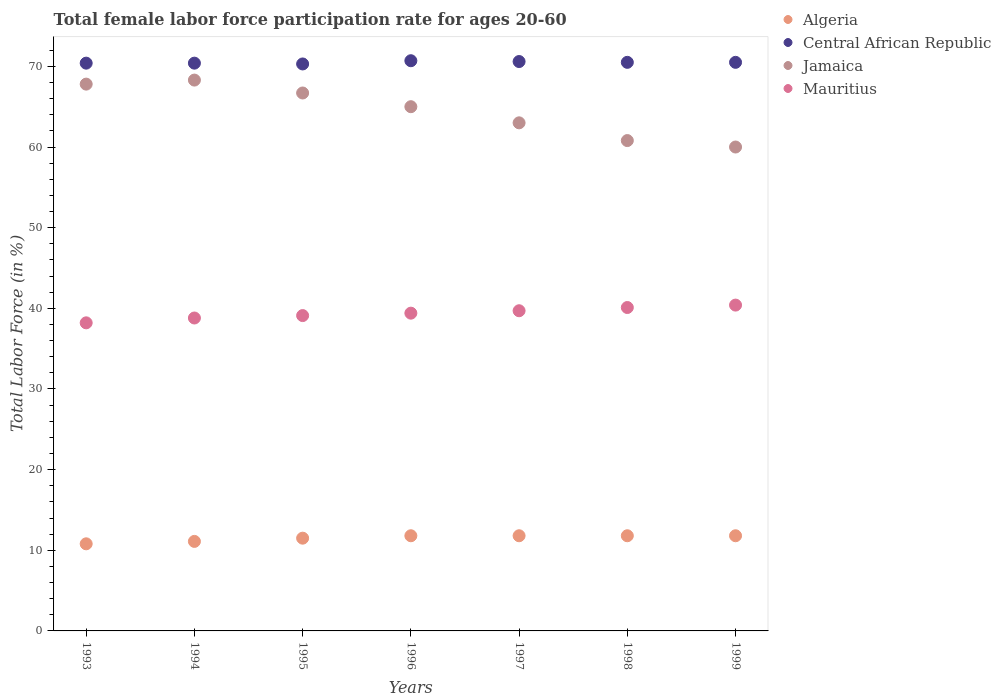What is the female labor force participation rate in Algeria in 1998?
Provide a short and direct response. 11.8. Across all years, what is the maximum female labor force participation rate in Jamaica?
Give a very brief answer. 68.3. In which year was the female labor force participation rate in Algeria minimum?
Ensure brevity in your answer.  1993. What is the total female labor force participation rate in Algeria in the graph?
Provide a short and direct response. 80.6. What is the difference between the female labor force participation rate in Central African Republic in 1994 and that in 1997?
Ensure brevity in your answer.  -0.2. What is the difference between the female labor force participation rate in Central African Republic in 1997 and the female labor force participation rate in Algeria in 1995?
Make the answer very short. 59.1. What is the average female labor force participation rate in Mauritius per year?
Your answer should be compact. 39.39. In how many years, is the female labor force participation rate in Algeria greater than 22 %?
Your answer should be compact. 0. What is the ratio of the female labor force participation rate in Jamaica in 1997 to that in 1998?
Offer a very short reply. 1.04. What is the difference between the highest and the second highest female labor force participation rate in Mauritius?
Keep it short and to the point. 0.3. What is the difference between the highest and the lowest female labor force participation rate in Mauritius?
Give a very brief answer. 2.2. Is the sum of the female labor force participation rate in Mauritius in 1994 and 1996 greater than the maximum female labor force participation rate in Algeria across all years?
Your response must be concise. Yes. Is it the case that in every year, the sum of the female labor force participation rate in Mauritius and female labor force participation rate in Central African Republic  is greater than the sum of female labor force participation rate in Algeria and female labor force participation rate in Jamaica?
Provide a succinct answer. No. Is it the case that in every year, the sum of the female labor force participation rate in Jamaica and female labor force participation rate in Algeria  is greater than the female labor force participation rate in Central African Republic?
Give a very brief answer. Yes. Does the female labor force participation rate in Jamaica monotonically increase over the years?
Give a very brief answer. No. Is the female labor force participation rate in Algeria strictly greater than the female labor force participation rate in Central African Republic over the years?
Offer a terse response. No. How many years are there in the graph?
Give a very brief answer. 7. Are the values on the major ticks of Y-axis written in scientific E-notation?
Give a very brief answer. No. Does the graph contain any zero values?
Your answer should be compact. No. Does the graph contain grids?
Make the answer very short. No. Where does the legend appear in the graph?
Make the answer very short. Top right. How are the legend labels stacked?
Your response must be concise. Vertical. What is the title of the graph?
Provide a short and direct response. Total female labor force participation rate for ages 20-60. Does "Mauritius" appear as one of the legend labels in the graph?
Your answer should be very brief. Yes. What is the label or title of the X-axis?
Keep it short and to the point. Years. What is the Total Labor Force (in %) of Algeria in 1993?
Your answer should be compact. 10.8. What is the Total Labor Force (in %) of Central African Republic in 1993?
Make the answer very short. 70.4. What is the Total Labor Force (in %) of Jamaica in 1993?
Give a very brief answer. 67.8. What is the Total Labor Force (in %) in Mauritius in 1993?
Your answer should be compact. 38.2. What is the Total Labor Force (in %) in Algeria in 1994?
Keep it short and to the point. 11.1. What is the Total Labor Force (in %) of Central African Republic in 1994?
Offer a very short reply. 70.4. What is the Total Labor Force (in %) in Jamaica in 1994?
Your answer should be compact. 68.3. What is the Total Labor Force (in %) in Mauritius in 1994?
Keep it short and to the point. 38.8. What is the Total Labor Force (in %) in Algeria in 1995?
Ensure brevity in your answer.  11.5. What is the Total Labor Force (in %) of Central African Republic in 1995?
Your answer should be very brief. 70.3. What is the Total Labor Force (in %) of Jamaica in 1995?
Provide a succinct answer. 66.7. What is the Total Labor Force (in %) of Mauritius in 1995?
Offer a terse response. 39.1. What is the Total Labor Force (in %) of Algeria in 1996?
Offer a terse response. 11.8. What is the Total Labor Force (in %) of Central African Republic in 1996?
Offer a terse response. 70.7. What is the Total Labor Force (in %) of Jamaica in 1996?
Offer a terse response. 65. What is the Total Labor Force (in %) of Mauritius in 1996?
Your answer should be very brief. 39.4. What is the Total Labor Force (in %) in Algeria in 1997?
Provide a succinct answer. 11.8. What is the Total Labor Force (in %) of Central African Republic in 1997?
Ensure brevity in your answer.  70.6. What is the Total Labor Force (in %) in Mauritius in 1997?
Keep it short and to the point. 39.7. What is the Total Labor Force (in %) in Algeria in 1998?
Your answer should be very brief. 11.8. What is the Total Labor Force (in %) of Central African Republic in 1998?
Make the answer very short. 70.5. What is the Total Labor Force (in %) in Jamaica in 1998?
Give a very brief answer. 60.8. What is the Total Labor Force (in %) of Mauritius in 1998?
Provide a succinct answer. 40.1. What is the Total Labor Force (in %) in Algeria in 1999?
Offer a very short reply. 11.8. What is the Total Labor Force (in %) of Central African Republic in 1999?
Keep it short and to the point. 70.5. What is the Total Labor Force (in %) in Mauritius in 1999?
Ensure brevity in your answer.  40.4. Across all years, what is the maximum Total Labor Force (in %) of Algeria?
Ensure brevity in your answer.  11.8. Across all years, what is the maximum Total Labor Force (in %) in Central African Republic?
Your response must be concise. 70.7. Across all years, what is the maximum Total Labor Force (in %) of Jamaica?
Offer a very short reply. 68.3. Across all years, what is the maximum Total Labor Force (in %) of Mauritius?
Your answer should be compact. 40.4. Across all years, what is the minimum Total Labor Force (in %) in Algeria?
Your answer should be compact. 10.8. Across all years, what is the minimum Total Labor Force (in %) in Central African Republic?
Make the answer very short. 70.3. Across all years, what is the minimum Total Labor Force (in %) of Mauritius?
Your answer should be very brief. 38.2. What is the total Total Labor Force (in %) in Algeria in the graph?
Your answer should be very brief. 80.6. What is the total Total Labor Force (in %) of Central African Republic in the graph?
Keep it short and to the point. 493.4. What is the total Total Labor Force (in %) in Jamaica in the graph?
Offer a very short reply. 451.6. What is the total Total Labor Force (in %) of Mauritius in the graph?
Offer a terse response. 275.7. What is the difference between the Total Labor Force (in %) in Algeria in 1993 and that in 1994?
Your answer should be very brief. -0.3. What is the difference between the Total Labor Force (in %) of Jamaica in 1993 and that in 1995?
Offer a very short reply. 1.1. What is the difference between the Total Labor Force (in %) of Algeria in 1993 and that in 1998?
Provide a succinct answer. -1. What is the difference between the Total Labor Force (in %) of Jamaica in 1993 and that in 1998?
Provide a succinct answer. 7. What is the difference between the Total Labor Force (in %) of Central African Republic in 1993 and that in 1999?
Make the answer very short. -0.1. What is the difference between the Total Labor Force (in %) of Algeria in 1994 and that in 1995?
Your answer should be very brief. -0.4. What is the difference between the Total Labor Force (in %) in Jamaica in 1994 and that in 1995?
Your answer should be very brief. 1.6. What is the difference between the Total Labor Force (in %) of Mauritius in 1994 and that in 1995?
Provide a succinct answer. -0.3. What is the difference between the Total Labor Force (in %) of Algeria in 1994 and that in 1996?
Your answer should be very brief. -0.7. What is the difference between the Total Labor Force (in %) of Jamaica in 1994 and that in 1996?
Give a very brief answer. 3.3. What is the difference between the Total Labor Force (in %) of Mauritius in 1994 and that in 1996?
Your answer should be compact. -0.6. What is the difference between the Total Labor Force (in %) in Algeria in 1994 and that in 1997?
Offer a very short reply. -0.7. What is the difference between the Total Labor Force (in %) in Jamaica in 1994 and that in 1997?
Provide a short and direct response. 5.3. What is the difference between the Total Labor Force (in %) of Central African Republic in 1994 and that in 1998?
Make the answer very short. -0.1. What is the difference between the Total Labor Force (in %) in Mauritius in 1994 and that in 1998?
Make the answer very short. -1.3. What is the difference between the Total Labor Force (in %) of Algeria in 1994 and that in 1999?
Offer a terse response. -0.7. What is the difference between the Total Labor Force (in %) of Mauritius in 1994 and that in 1999?
Your response must be concise. -1.6. What is the difference between the Total Labor Force (in %) of Algeria in 1995 and that in 1996?
Ensure brevity in your answer.  -0.3. What is the difference between the Total Labor Force (in %) of Central African Republic in 1995 and that in 1996?
Your answer should be very brief. -0.4. What is the difference between the Total Labor Force (in %) in Jamaica in 1995 and that in 1996?
Make the answer very short. 1.7. What is the difference between the Total Labor Force (in %) of Algeria in 1995 and that in 1997?
Your response must be concise. -0.3. What is the difference between the Total Labor Force (in %) of Central African Republic in 1995 and that in 1997?
Provide a short and direct response. -0.3. What is the difference between the Total Labor Force (in %) in Algeria in 1995 and that in 1998?
Provide a short and direct response. -0.3. What is the difference between the Total Labor Force (in %) in Mauritius in 1995 and that in 1998?
Your answer should be compact. -1. What is the difference between the Total Labor Force (in %) of Central African Republic in 1996 and that in 1997?
Your answer should be very brief. 0.1. What is the difference between the Total Labor Force (in %) of Mauritius in 1996 and that in 1997?
Offer a very short reply. -0.3. What is the difference between the Total Labor Force (in %) of Algeria in 1996 and that in 1998?
Give a very brief answer. 0. What is the difference between the Total Labor Force (in %) of Mauritius in 1996 and that in 1998?
Offer a terse response. -0.7. What is the difference between the Total Labor Force (in %) of Algeria in 1996 and that in 1999?
Give a very brief answer. 0. What is the difference between the Total Labor Force (in %) in Central African Republic in 1996 and that in 1999?
Offer a very short reply. 0.2. What is the difference between the Total Labor Force (in %) of Mauritius in 1996 and that in 1999?
Your answer should be compact. -1. What is the difference between the Total Labor Force (in %) of Algeria in 1997 and that in 1998?
Your answer should be very brief. 0. What is the difference between the Total Labor Force (in %) of Jamaica in 1997 and that in 1998?
Your response must be concise. 2.2. What is the difference between the Total Labor Force (in %) in Central African Republic in 1997 and that in 1999?
Offer a very short reply. 0.1. What is the difference between the Total Labor Force (in %) in Mauritius in 1997 and that in 1999?
Make the answer very short. -0.7. What is the difference between the Total Labor Force (in %) of Algeria in 1998 and that in 1999?
Keep it short and to the point. 0. What is the difference between the Total Labor Force (in %) in Central African Republic in 1998 and that in 1999?
Ensure brevity in your answer.  0. What is the difference between the Total Labor Force (in %) in Algeria in 1993 and the Total Labor Force (in %) in Central African Republic in 1994?
Offer a terse response. -59.6. What is the difference between the Total Labor Force (in %) of Algeria in 1993 and the Total Labor Force (in %) of Jamaica in 1994?
Provide a short and direct response. -57.5. What is the difference between the Total Labor Force (in %) of Central African Republic in 1993 and the Total Labor Force (in %) of Jamaica in 1994?
Provide a succinct answer. 2.1. What is the difference between the Total Labor Force (in %) of Central African Republic in 1993 and the Total Labor Force (in %) of Mauritius in 1994?
Provide a short and direct response. 31.6. What is the difference between the Total Labor Force (in %) of Algeria in 1993 and the Total Labor Force (in %) of Central African Republic in 1995?
Your response must be concise. -59.5. What is the difference between the Total Labor Force (in %) of Algeria in 1993 and the Total Labor Force (in %) of Jamaica in 1995?
Make the answer very short. -55.9. What is the difference between the Total Labor Force (in %) of Algeria in 1993 and the Total Labor Force (in %) of Mauritius in 1995?
Make the answer very short. -28.3. What is the difference between the Total Labor Force (in %) in Central African Republic in 1993 and the Total Labor Force (in %) in Jamaica in 1995?
Ensure brevity in your answer.  3.7. What is the difference between the Total Labor Force (in %) in Central African Republic in 1993 and the Total Labor Force (in %) in Mauritius in 1995?
Ensure brevity in your answer.  31.3. What is the difference between the Total Labor Force (in %) of Jamaica in 1993 and the Total Labor Force (in %) of Mauritius in 1995?
Provide a succinct answer. 28.7. What is the difference between the Total Labor Force (in %) of Algeria in 1993 and the Total Labor Force (in %) of Central African Republic in 1996?
Provide a succinct answer. -59.9. What is the difference between the Total Labor Force (in %) of Algeria in 1993 and the Total Labor Force (in %) of Jamaica in 1996?
Offer a terse response. -54.2. What is the difference between the Total Labor Force (in %) in Algeria in 1993 and the Total Labor Force (in %) in Mauritius in 1996?
Your answer should be very brief. -28.6. What is the difference between the Total Labor Force (in %) in Jamaica in 1993 and the Total Labor Force (in %) in Mauritius in 1996?
Give a very brief answer. 28.4. What is the difference between the Total Labor Force (in %) of Algeria in 1993 and the Total Labor Force (in %) of Central African Republic in 1997?
Your answer should be compact. -59.8. What is the difference between the Total Labor Force (in %) of Algeria in 1993 and the Total Labor Force (in %) of Jamaica in 1997?
Your answer should be compact. -52.2. What is the difference between the Total Labor Force (in %) of Algeria in 1993 and the Total Labor Force (in %) of Mauritius in 1997?
Your answer should be compact. -28.9. What is the difference between the Total Labor Force (in %) in Central African Republic in 1993 and the Total Labor Force (in %) in Mauritius in 1997?
Provide a succinct answer. 30.7. What is the difference between the Total Labor Force (in %) in Jamaica in 1993 and the Total Labor Force (in %) in Mauritius in 1997?
Offer a very short reply. 28.1. What is the difference between the Total Labor Force (in %) in Algeria in 1993 and the Total Labor Force (in %) in Central African Republic in 1998?
Ensure brevity in your answer.  -59.7. What is the difference between the Total Labor Force (in %) in Algeria in 1993 and the Total Labor Force (in %) in Mauritius in 1998?
Provide a short and direct response. -29.3. What is the difference between the Total Labor Force (in %) in Central African Republic in 1993 and the Total Labor Force (in %) in Mauritius in 1998?
Your answer should be compact. 30.3. What is the difference between the Total Labor Force (in %) in Jamaica in 1993 and the Total Labor Force (in %) in Mauritius in 1998?
Provide a short and direct response. 27.7. What is the difference between the Total Labor Force (in %) of Algeria in 1993 and the Total Labor Force (in %) of Central African Republic in 1999?
Give a very brief answer. -59.7. What is the difference between the Total Labor Force (in %) of Algeria in 1993 and the Total Labor Force (in %) of Jamaica in 1999?
Make the answer very short. -49.2. What is the difference between the Total Labor Force (in %) of Algeria in 1993 and the Total Labor Force (in %) of Mauritius in 1999?
Your answer should be very brief. -29.6. What is the difference between the Total Labor Force (in %) in Central African Republic in 1993 and the Total Labor Force (in %) in Jamaica in 1999?
Ensure brevity in your answer.  10.4. What is the difference between the Total Labor Force (in %) in Jamaica in 1993 and the Total Labor Force (in %) in Mauritius in 1999?
Ensure brevity in your answer.  27.4. What is the difference between the Total Labor Force (in %) in Algeria in 1994 and the Total Labor Force (in %) in Central African Republic in 1995?
Offer a very short reply. -59.2. What is the difference between the Total Labor Force (in %) in Algeria in 1994 and the Total Labor Force (in %) in Jamaica in 1995?
Your response must be concise. -55.6. What is the difference between the Total Labor Force (in %) of Algeria in 1994 and the Total Labor Force (in %) of Mauritius in 1995?
Your response must be concise. -28. What is the difference between the Total Labor Force (in %) in Central African Republic in 1994 and the Total Labor Force (in %) in Jamaica in 1995?
Provide a succinct answer. 3.7. What is the difference between the Total Labor Force (in %) in Central African Republic in 1994 and the Total Labor Force (in %) in Mauritius in 1995?
Your answer should be very brief. 31.3. What is the difference between the Total Labor Force (in %) in Jamaica in 1994 and the Total Labor Force (in %) in Mauritius in 1995?
Provide a short and direct response. 29.2. What is the difference between the Total Labor Force (in %) of Algeria in 1994 and the Total Labor Force (in %) of Central African Republic in 1996?
Give a very brief answer. -59.6. What is the difference between the Total Labor Force (in %) in Algeria in 1994 and the Total Labor Force (in %) in Jamaica in 1996?
Your answer should be very brief. -53.9. What is the difference between the Total Labor Force (in %) in Algeria in 1994 and the Total Labor Force (in %) in Mauritius in 1996?
Ensure brevity in your answer.  -28.3. What is the difference between the Total Labor Force (in %) of Central African Republic in 1994 and the Total Labor Force (in %) of Jamaica in 1996?
Offer a terse response. 5.4. What is the difference between the Total Labor Force (in %) in Central African Republic in 1994 and the Total Labor Force (in %) in Mauritius in 1996?
Provide a short and direct response. 31. What is the difference between the Total Labor Force (in %) of Jamaica in 1994 and the Total Labor Force (in %) of Mauritius in 1996?
Your answer should be compact. 28.9. What is the difference between the Total Labor Force (in %) of Algeria in 1994 and the Total Labor Force (in %) of Central African Republic in 1997?
Provide a succinct answer. -59.5. What is the difference between the Total Labor Force (in %) in Algeria in 1994 and the Total Labor Force (in %) in Jamaica in 1997?
Your answer should be very brief. -51.9. What is the difference between the Total Labor Force (in %) of Algeria in 1994 and the Total Labor Force (in %) of Mauritius in 1997?
Give a very brief answer. -28.6. What is the difference between the Total Labor Force (in %) in Central African Republic in 1994 and the Total Labor Force (in %) in Jamaica in 1997?
Your answer should be compact. 7.4. What is the difference between the Total Labor Force (in %) in Central African Republic in 1994 and the Total Labor Force (in %) in Mauritius in 1997?
Your answer should be compact. 30.7. What is the difference between the Total Labor Force (in %) of Jamaica in 1994 and the Total Labor Force (in %) of Mauritius in 1997?
Your response must be concise. 28.6. What is the difference between the Total Labor Force (in %) in Algeria in 1994 and the Total Labor Force (in %) in Central African Republic in 1998?
Give a very brief answer. -59.4. What is the difference between the Total Labor Force (in %) in Algeria in 1994 and the Total Labor Force (in %) in Jamaica in 1998?
Your response must be concise. -49.7. What is the difference between the Total Labor Force (in %) of Algeria in 1994 and the Total Labor Force (in %) of Mauritius in 1998?
Give a very brief answer. -29. What is the difference between the Total Labor Force (in %) in Central African Republic in 1994 and the Total Labor Force (in %) in Jamaica in 1998?
Offer a very short reply. 9.6. What is the difference between the Total Labor Force (in %) in Central African Republic in 1994 and the Total Labor Force (in %) in Mauritius in 1998?
Ensure brevity in your answer.  30.3. What is the difference between the Total Labor Force (in %) in Jamaica in 1994 and the Total Labor Force (in %) in Mauritius in 1998?
Ensure brevity in your answer.  28.2. What is the difference between the Total Labor Force (in %) in Algeria in 1994 and the Total Labor Force (in %) in Central African Republic in 1999?
Make the answer very short. -59.4. What is the difference between the Total Labor Force (in %) in Algeria in 1994 and the Total Labor Force (in %) in Jamaica in 1999?
Provide a short and direct response. -48.9. What is the difference between the Total Labor Force (in %) in Algeria in 1994 and the Total Labor Force (in %) in Mauritius in 1999?
Provide a short and direct response. -29.3. What is the difference between the Total Labor Force (in %) of Central African Republic in 1994 and the Total Labor Force (in %) of Jamaica in 1999?
Make the answer very short. 10.4. What is the difference between the Total Labor Force (in %) of Central African Republic in 1994 and the Total Labor Force (in %) of Mauritius in 1999?
Provide a succinct answer. 30. What is the difference between the Total Labor Force (in %) of Jamaica in 1994 and the Total Labor Force (in %) of Mauritius in 1999?
Provide a succinct answer. 27.9. What is the difference between the Total Labor Force (in %) in Algeria in 1995 and the Total Labor Force (in %) in Central African Republic in 1996?
Give a very brief answer. -59.2. What is the difference between the Total Labor Force (in %) in Algeria in 1995 and the Total Labor Force (in %) in Jamaica in 1996?
Your response must be concise. -53.5. What is the difference between the Total Labor Force (in %) in Algeria in 1995 and the Total Labor Force (in %) in Mauritius in 1996?
Provide a succinct answer. -27.9. What is the difference between the Total Labor Force (in %) in Central African Republic in 1995 and the Total Labor Force (in %) in Jamaica in 1996?
Your response must be concise. 5.3. What is the difference between the Total Labor Force (in %) of Central African Republic in 1995 and the Total Labor Force (in %) of Mauritius in 1996?
Keep it short and to the point. 30.9. What is the difference between the Total Labor Force (in %) in Jamaica in 1995 and the Total Labor Force (in %) in Mauritius in 1996?
Give a very brief answer. 27.3. What is the difference between the Total Labor Force (in %) of Algeria in 1995 and the Total Labor Force (in %) of Central African Republic in 1997?
Your response must be concise. -59.1. What is the difference between the Total Labor Force (in %) of Algeria in 1995 and the Total Labor Force (in %) of Jamaica in 1997?
Give a very brief answer. -51.5. What is the difference between the Total Labor Force (in %) in Algeria in 1995 and the Total Labor Force (in %) in Mauritius in 1997?
Ensure brevity in your answer.  -28.2. What is the difference between the Total Labor Force (in %) in Central African Republic in 1995 and the Total Labor Force (in %) in Jamaica in 1997?
Provide a short and direct response. 7.3. What is the difference between the Total Labor Force (in %) in Central African Republic in 1995 and the Total Labor Force (in %) in Mauritius in 1997?
Give a very brief answer. 30.6. What is the difference between the Total Labor Force (in %) in Jamaica in 1995 and the Total Labor Force (in %) in Mauritius in 1997?
Your response must be concise. 27. What is the difference between the Total Labor Force (in %) in Algeria in 1995 and the Total Labor Force (in %) in Central African Republic in 1998?
Offer a terse response. -59. What is the difference between the Total Labor Force (in %) of Algeria in 1995 and the Total Labor Force (in %) of Jamaica in 1998?
Make the answer very short. -49.3. What is the difference between the Total Labor Force (in %) in Algeria in 1995 and the Total Labor Force (in %) in Mauritius in 1998?
Your answer should be compact. -28.6. What is the difference between the Total Labor Force (in %) of Central African Republic in 1995 and the Total Labor Force (in %) of Jamaica in 1998?
Keep it short and to the point. 9.5. What is the difference between the Total Labor Force (in %) in Central African Republic in 1995 and the Total Labor Force (in %) in Mauritius in 1998?
Provide a short and direct response. 30.2. What is the difference between the Total Labor Force (in %) in Jamaica in 1995 and the Total Labor Force (in %) in Mauritius in 1998?
Give a very brief answer. 26.6. What is the difference between the Total Labor Force (in %) in Algeria in 1995 and the Total Labor Force (in %) in Central African Republic in 1999?
Your answer should be compact. -59. What is the difference between the Total Labor Force (in %) in Algeria in 1995 and the Total Labor Force (in %) in Jamaica in 1999?
Provide a short and direct response. -48.5. What is the difference between the Total Labor Force (in %) of Algeria in 1995 and the Total Labor Force (in %) of Mauritius in 1999?
Your answer should be very brief. -28.9. What is the difference between the Total Labor Force (in %) of Central African Republic in 1995 and the Total Labor Force (in %) of Mauritius in 1999?
Provide a short and direct response. 29.9. What is the difference between the Total Labor Force (in %) of Jamaica in 1995 and the Total Labor Force (in %) of Mauritius in 1999?
Your answer should be very brief. 26.3. What is the difference between the Total Labor Force (in %) of Algeria in 1996 and the Total Labor Force (in %) of Central African Republic in 1997?
Provide a succinct answer. -58.8. What is the difference between the Total Labor Force (in %) in Algeria in 1996 and the Total Labor Force (in %) in Jamaica in 1997?
Keep it short and to the point. -51.2. What is the difference between the Total Labor Force (in %) of Algeria in 1996 and the Total Labor Force (in %) of Mauritius in 1997?
Give a very brief answer. -27.9. What is the difference between the Total Labor Force (in %) of Central African Republic in 1996 and the Total Labor Force (in %) of Jamaica in 1997?
Your answer should be compact. 7.7. What is the difference between the Total Labor Force (in %) of Central African Republic in 1996 and the Total Labor Force (in %) of Mauritius in 1997?
Your response must be concise. 31. What is the difference between the Total Labor Force (in %) in Jamaica in 1996 and the Total Labor Force (in %) in Mauritius in 1997?
Provide a short and direct response. 25.3. What is the difference between the Total Labor Force (in %) of Algeria in 1996 and the Total Labor Force (in %) of Central African Republic in 1998?
Make the answer very short. -58.7. What is the difference between the Total Labor Force (in %) in Algeria in 1996 and the Total Labor Force (in %) in Jamaica in 1998?
Keep it short and to the point. -49. What is the difference between the Total Labor Force (in %) in Algeria in 1996 and the Total Labor Force (in %) in Mauritius in 1998?
Offer a terse response. -28.3. What is the difference between the Total Labor Force (in %) in Central African Republic in 1996 and the Total Labor Force (in %) in Mauritius in 1998?
Your answer should be very brief. 30.6. What is the difference between the Total Labor Force (in %) in Jamaica in 1996 and the Total Labor Force (in %) in Mauritius in 1998?
Keep it short and to the point. 24.9. What is the difference between the Total Labor Force (in %) of Algeria in 1996 and the Total Labor Force (in %) of Central African Republic in 1999?
Offer a very short reply. -58.7. What is the difference between the Total Labor Force (in %) in Algeria in 1996 and the Total Labor Force (in %) in Jamaica in 1999?
Keep it short and to the point. -48.2. What is the difference between the Total Labor Force (in %) in Algeria in 1996 and the Total Labor Force (in %) in Mauritius in 1999?
Your answer should be very brief. -28.6. What is the difference between the Total Labor Force (in %) in Central African Republic in 1996 and the Total Labor Force (in %) in Mauritius in 1999?
Provide a short and direct response. 30.3. What is the difference between the Total Labor Force (in %) of Jamaica in 1996 and the Total Labor Force (in %) of Mauritius in 1999?
Your response must be concise. 24.6. What is the difference between the Total Labor Force (in %) in Algeria in 1997 and the Total Labor Force (in %) in Central African Republic in 1998?
Provide a short and direct response. -58.7. What is the difference between the Total Labor Force (in %) in Algeria in 1997 and the Total Labor Force (in %) in Jamaica in 1998?
Ensure brevity in your answer.  -49. What is the difference between the Total Labor Force (in %) in Algeria in 1997 and the Total Labor Force (in %) in Mauritius in 1998?
Your answer should be compact. -28.3. What is the difference between the Total Labor Force (in %) of Central African Republic in 1997 and the Total Labor Force (in %) of Mauritius in 1998?
Ensure brevity in your answer.  30.5. What is the difference between the Total Labor Force (in %) of Jamaica in 1997 and the Total Labor Force (in %) of Mauritius in 1998?
Provide a short and direct response. 22.9. What is the difference between the Total Labor Force (in %) in Algeria in 1997 and the Total Labor Force (in %) in Central African Republic in 1999?
Your answer should be compact. -58.7. What is the difference between the Total Labor Force (in %) in Algeria in 1997 and the Total Labor Force (in %) in Jamaica in 1999?
Ensure brevity in your answer.  -48.2. What is the difference between the Total Labor Force (in %) in Algeria in 1997 and the Total Labor Force (in %) in Mauritius in 1999?
Offer a terse response. -28.6. What is the difference between the Total Labor Force (in %) of Central African Republic in 1997 and the Total Labor Force (in %) of Jamaica in 1999?
Your answer should be very brief. 10.6. What is the difference between the Total Labor Force (in %) in Central African Republic in 1997 and the Total Labor Force (in %) in Mauritius in 1999?
Provide a short and direct response. 30.2. What is the difference between the Total Labor Force (in %) of Jamaica in 1997 and the Total Labor Force (in %) of Mauritius in 1999?
Provide a succinct answer. 22.6. What is the difference between the Total Labor Force (in %) of Algeria in 1998 and the Total Labor Force (in %) of Central African Republic in 1999?
Ensure brevity in your answer.  -58.7. What is the difference between the Total Labor Force (in %) in Algeria in 1998 and the Total Labor Force (in %) in Jamaica in 1999?
Keep it short and to the point. -48.2. What is the difference between the Total Labor Force (in %) in Algeria in 1998 and the Total Labor Force (in %) in Mauritius in 1999?
Your answer should be compact. -28.6. What is the difference between the Total Labor Force (in %) of Central African Republic in 1998 and the Total Labor Force (in %) of Mauritius in 1999?
Your response must be concise. 30.1. What is the difference between the Total Labor Force (in %) in Jamaica in 1998 and the Total Labor Force (in %) in Mauritius in 1999?
Provide a short and direct response. 20.4. What is the average Total Labor Force (in %) of Algeria per year?
Provide a short and direct response. 11.51. What is the average Total Labor Force (in %) in Central African Republic per year?
Provide a succinct answer. 70.49. What is the average Total Labor Force (in %) in Jamaica per year?
Your answer should be very brief. 64.51. What is the average Total Labor Force (in %) in Mauritius per year?
Keep it short and to the point. 39.39. In the year 1993, what is the difference between the Total Labor Force (in %) in Algeria and Total Labor Force (in %) in Central African Republic?
Offer a very short reply. -59.6. In the year 1993, what is the difference between the Total Labor Force (in %) in Algeria and Total Labor Force (in %) in Jamaica?
Offer a terse response. -57. In the year 1993, what is the difference between the Total Labor Force (in %) in Algeria and Total Labor Force (in %) in Mauritius?
Make the answer very short. -27.4. In the year 1993, what is the difference between the Total Labor Force (in %) of Central African Republic and Total Labor Force (in %) of Mauritius?
Provide a short and direct response. 32.2. In the year 1993, what is the difference between the Total Labor Force (in %) in Jamaica and Total Labor Force (in %) in Mauritius?
Your answer should be compact. 29.6. In the year 1994, what is the difference between the Total Labor Force (in %) in Algeria and Total Labor Force (in %) in Central African Republic?
Give a very brief answer. -59.3. In the year 1994, what is the difference between the Total Labor Force (in %) in Algeria and Total Labor Force (in %) in Jamaica?
Your response must be concise. -57.2. In the year 1994, what is the difference between the Total Labor Force (in %) in Algeria and Total Labor Force (in %) in Mauritius?
Ensure brevity in your answer.  -27.7. In the year 1994, what is the difference between the Total Labor Force (in %) in Central African Republic and Total Labor Force (in %) in Jamaica?
Keep it short and to the point. 2.1. In the year 1994, what is the difference between the Total Labor Force (in %) of Central African Republic and Total Labor Force (in %) of Mauritius?
Ensure brevity in your answer.  31.6. In the year 1994, what is the difference between the Total Labor Force (in %) of Jamaica and Total Labor Force (in %) of Mauritius?
Make the answer very short. 29.5. In the year 1995, what is the difference between the Total Labor Force (in %) in Algeria and Total Labor Force (in %) in Central African Republic?
Give a very brief answer. -58.8. In the year 1995, what is the difference between the Total Labor Force (in %) of Algeria and Total Labor Force (in %) of Jamaica?
Provide a succinct answer. -55.2. In the year 1995, what is the difference between the Total Labor Force (in %) of Algeria and Total Labor Force (in %) of Mauritius?
Your response must be concise. -27.6. In the year 1995, what is the difference between the Total Labor Force (in %) in Central African Republic and Total Labor Force (in %) in Jamaica?
Your answer should be very brief. 3.6. In the year 1995, what is the difference between the Total Labor Force (in %) in Central African Republic and Total Labor Force (in %) in Mauritius?
Provide a short and direct response. 31.2. In the year 1995, what is the difference between the Total Labor Force (in %) of Jamaica and Total Labor Force (in %) of Mauritius?
Keep it short and to the point. 27.6. In the year 1996, what is the difference between the Total Labor Force (in %) of Algeria and Total Labor Force (in %) of Central African Republic?
Ensure brevity in your answer.  -58.9. In the year 1996, what is the difference between the Total Labor Force (in %) in Algeria and Total Labor Force (in %) in Jamaica?
Make the answer very short. -53.2. In the year 1996, what is the difference between the Total Labor Force (in %) of Algeria and Total Labor Force (in %) of Mauritius?
Keep it short and to the point. -27.6. In the year 1996, what is the difference between the Total Labor Force (in %) in Central African Republic and Total Labor Force (in %) in Jamaica?
Give a very brief answer. 5.7. In the year 1996, what is the difference between the Total Labor Force (in %) in Central African Republic and Total Labor Force (in %) in Mauritius?
Give a very brief answer. 31.3. In the year 1996, what is the difference between the Total Labor Force (in %) in Jamaica and Total Labor Force (in %) in Mauritius?
Your answer should be compact. 25.6. In the year 1997, what is the difference between the Total Labor Force (in %) in Algeria and Total Labor Force (in %) in Central African Republic?
Offer a terse response. -58.8. In the year 1997, what is the difference between the Total Labor Force (in %) of Algeria and Total Labor Force (in %) of Jamaica?
Ensure brevity in your answer.  -51.2. In the year 1997, what is the difference between the Total Labor Force (in %) in Algeria and Total Labor Force (in %) in Mauritius?
Make the answer very short. -27.9. In the year 1997, what is the difference between the Total Labor Force (in %) of Central African Republic and Total Labor Force (in %) of Jamaica?
Provide a succinct answer. 7.6. In the year 1997, what is the difference between the Total Labor Force (in %) of Central African Republic and Total Labor Force (in %) of Mauritius?
Keep it short and to the point. 30.9. In the year 1997, what is the difference between the Total Labor Force (in %) of Jamaica and Total Labor Force (in %) of Mauritius?
Offer a very short reply. 23.3. In the year 1998, what is the difference between the Total Labor Force (in %) in Algeria and Total Labor Force (in %) in Central African Republic?
Your answer should be compact. -58.7. In the year 1998, what is the difference between the Total Labor Force (in %) in Algeria and Total Labor Force (in %) in Jamaica?
Ensure brevity in your answer.  -49. In the year 1998, what is the difference between the Total Labor Force (in %) in Algeria and Total Labor Force (in %) in Mauritius?
Make the answer very short. -28.3. In the year 1998, what is the difference between the Total Labor Force (in %) of Central African Republic and Total Labor Force (in %) of Jamaica?
Offer a terse response. 9.7. In the year 1998, what is the difference between the Total Labor Force (in %) of Central African Republic and Total Labor Force (in %) of Mauritius?
Make the answer very short. 30.4. In the year 1998, what is the difference between the Total Labor Force (in %) of Jamaica and Total Labor Force (in %) of Mauritius?
Keep it short and to the point. 20.7. In the year 1999, what is the difference between the Total Labor Force (in %) of Algeria and Total Labor Force (in %) of Central African Republic?
Keep it short and to the point. -58.7. In the year 1999, what is the difference between the Total Labor Force (in %) of Algeria and Total Labor Force (in %) of Jamaica?
Your response must be concise. -48.2. In the year 1999, what is the difference between the Total Labor Force (in %) of Algeria and Total Labor Force (in %) of Mauritius?
Make the answer very short. -28.6. In the year 1999, what is the difference between the Total Labor Force (in %) of Central African Republic and Total Labor Force (in %) of Jamaica?
Your answer should be compact. 10.5. In the year 1999, what is the difference between the Total Labor Force (in %) in Central African Republic and Total Labor Force (in %) in Mauritius?
Provide a short and direct response. 30.1. In the year 1999, what is the difference between the Total Labor Force (in %) of Jamaica and Total Labor Force (in %) of Mauritius?
Make the answer very short. 19.6. What is the ratio of the Total Labor Force (in %) in Algeria in 1993 to that in 1994?
Your answer should be compact. 0.97. What is the ratio of the Total Labor Force (in %) of Jamaica in 1993 to that in 1994?
Make the answer very short. 0.99. What is the ratio of the Total Labor Force (in %) in Mauritius in 1993 to that in 1994?
Ensure brevity in your answer.  0.98. What is the ratio of the Total Labor Force (in %) in Algeria in 1993 to that in 1995?
Provide a succinct answer. 0.94. What is the ratio of the Total Labor Force (in %) of Jamaica in 1993 to that in 1995?
Your answer should be very brief. 1.02. What is the ratio of the Total Labor Force (in %) of Algeria in 1993 to that in 1996?
Offer a terse response. 0.92. What is the ratio of the Total Labor Force (in %) of Jamaica in 1993 to that in 1996?
Offer a very short reply. 1.04. What is the ratio of the Total Labor Force (in %) in Mauritius in 1993 to that in 1996?
Your response must be concise. 0.97. What is the ratio of the Total Labor Force (in %) in Algeria in 1993 to that in 1997?
Offer a terse response. 0.92. What is the ratio of the Total Labor Force (in %) in Jamaica in 1993 to that in 1997?
Offer a terse response. 1.08. What is the ratio of the Total Labor Force (in %) in Mauritius in 1993 to that in 1997?
Your answer should be compact. 0.96. What is the ratio of the Total Labor Force (in %) of Algeria in 1993 to that in 1998?
Provide a succinct answer. 0.92. What is the ratio of the Total Labor Force (in %) of Jamaica in 1993 to that in 1998?
Keep it short and to the point. 1.12. What is the ratio of the Total Labor Force (in %) of Mauritius in 1993 to that in 1998?
Your response must be concise. 0.95. What is the ratio of the Total Labor Force (in %) in Algeria in 1993 to that in 1999?
Offer a terse response. 0.92. What is the ratio of the Total Labor Force (in %) of Central African Republic in 1993 to that in 1999?
Make the answer very short. 1. What is the ratio of the Total Labor Force (in %) in Jamaica in 1993 to that in 1999?
Provide a succinct answer. 1.13. What is the ratio of the Total Labor Force (in %) of Mauritius in 1993 to that in 1999?
Offer a very short reply. 0.95. What is the ratio of the Total Labor Force (in %) in Algeria in 1994 to that in 1995?
Keep it short and to the point. 0.97. What is the ratio of the Total Labor Force (in %) of Central African Republic in 1994 to that in 1995?
Your answer should be compact. 1. What is the ratio of the Total Labor Force (in %) of Mauritius in 1994 to that in 1995?
Your answer should be very brief. 0.99. What is the ratio of the Total Labor Force (in %) in Algeria in 1994 to that in 1996?
Give a very brief answer. 0.94. What is the ratio of the Total Labor Force (in %) in Central African Republic in 1994 to that in 1996?
Your response must be concise. 1. What is the ratio of the Total Labor Force (in %) of Jamaica in 1994 to that in 1996?
Your answer should be compact. 1.05. What is the ratio of the Total Labor Force (in %) in Algeria in 1994 to that in 1997?
Keep it short and to the point. 0.94. What is the ratio of the Total Labor Force (in %) in Jamaica in 1994 to that in 1997?
Keep it short and to the point. 1.08. What is the ratio of the Total Labor Force (in %) in Mauritius in 1994 to that in 1997?
Provide a succinct answer. 0.98. What is the ratio of the Total Labor Force (in %) in Algeria in 1994 to that in 1998?
Make the answer very short. 0.94. What is the ratio of the Total Labor Force (in %) of Central African Republic in 1994 to that in 1998?
Ensure brevity in your answer.  1. What is the ratio of the Total Labor Force (in %) of Jamaica in 1994 to that in 1998?
Offer a very short reply. 1.12. What is the ratio of the Total Labor Force (in %) in Mauritius in 1994 to that in 1998?
Provide a succinct answer. 0.97. What is the ratio of the Total Labor Force (in %) in Algeria in 1994 to that in 1999?
Give a very brief answer. 0.94. What is the ratio of the Total Labor Force (in %) in Jamaica in 1994 to that in 1999?
Your response must be concise. 1.14. What is the ratio of the Total Labor Force (in %) of Mauritius in 1994 to that in 1999?
Offer a terse response. 0.96. What is the ratio of the Total Labor Force (in %) in Algeria in 1995 to that in 1996?
Your answer should be compact. 0.97. What is the ratio of the Total Labor Force (in %) in Jamaica in 1995 to that in 1996?
Provide a short and direct response. 1.03. What is the ratio of the Total Labor Force (in %) in Algeria in 1995 to that in 1997?
Your response must be concise. 0.97. What is the ratio of the Total Labor Force (in %) of Central African Republic in 1995 to that in 1997?
Provide a short and direct response. 1. What is the ratio of the Total Labor Force (in %) in Jamaica in 1995 to that in 1997?
Your answer should be compact. 1.06. What is the ratio of the Total Labor Force (in %) in Mauritius in 1995 to that in 1997?
Your response must be concise. 0.98. What is the ratio of the Total Labor Force (in %) of Algeria in 1995 to that in 1998?
Your answer should be compact. 0.97. What is the ratio of the Total Labor Force (in %) in Central African Republic in 1995 to that in 1998?
Your answer should be compact. 1. What is the ratio of the Total Labor Force (in %) of Jamaica in 1995 to that in 1998?
Make the answer very short. 1.1. What is the ratio of the Total Labor Force (in %) of Mauritius in 1995 to that in 1998?
Your response must be concise. 0.98. What is the ratio of the Total Labor Force (in %) in Algeria in 1995 to that in 1999?
Provide a succinct answer. 0.97. What is the ratio of the Total Labor Force (in %) of Jamaica in 1995 to that in 1999?
Provide a short and direct response. 1.11. What is the ratio of the Total Labor Force (in %) of Mauritius in 1995 to that in 1999?
Offer a very short reply. 0.97. What is the ratio of the Total Labor Force (in %) of Jamaica in 1996 to that in 1997?
Keep it short and to the point. 1.03. What is the ratio of the Total Labor Force (in %) in Central African Republic in 1996 to that in 1998?
Provide a short and direct response. 1. What is the ratio of the Total Labor Force (in %) of Jamaica in 1996 to that in 1998?
Offer a terse response. 1.07. What is the ratio of the Total Labor Force (in %) of Mauritius in 1996 to that in 1998?
Ensure brevity in your answer.  0.98. What is the ratio of the Total Labor Force (in %) of Algeria in 1996 to that in 1999?
Provide a short and direct response. 1. What is the ratio of the Total Labor Force (in %) of Central African Republic in 1996 to that in 1999?
Provide a short and direct response. 1. What is the ratio of the Total Labor Force (in %) in Jamaica in 1996 to that in 1999?
Ensure brevity in your answer.  1.08. What is the ratio of the Total Labor Force (in %) of Mauritius in 1996 to that in 1999?
Ensure brevity in your answer.  0.98. What is the ratio of the Total Labor Force (in %) in Algeria in 1997 to that in 1998?
Offer a very short reply. 1. What is the ratio of the Total Labor Force (in %) of Jamaica in 1997 to that in 1998?
Keep it short and to the point. 1.04. What is the ratio of the Total Labor Force (in %) in Mauritius in 1997 to that in 1999?
Provide a short and direct response. 0.98. What is the ratio of the Total Labor Force (in %) in Jamaica in 1998 to that in 1999?
Offer a terse response. 1.01. What is the difference between the highest and the second highest Total Labor Force (in %) of Jamaica?
Make the answer very short. 0.5. What is the difference between the highest and the lowest Total Labor Force (in %) of Algeria?
Your answer should be compact. 1. What is the difference between the highest and the lowest Total Labor Force (in %) in Central African Republic?
Offer a very short reply. 0.4. What is the difference between the highest and the lowest Total Labor Force (in %) in Mauritius?
Give a very brief answer. 2.2. 